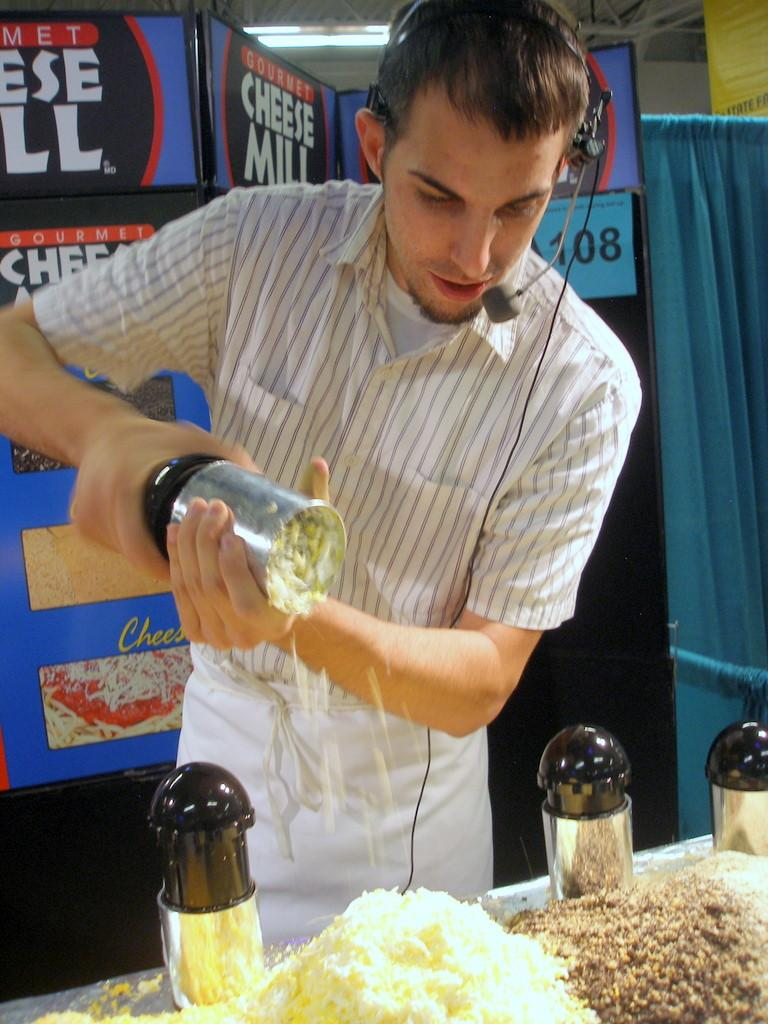<image>
Describe the image concisely. A man wearing a headset is grating a large pile of cheese at the Gourmet Cheese Mill. 